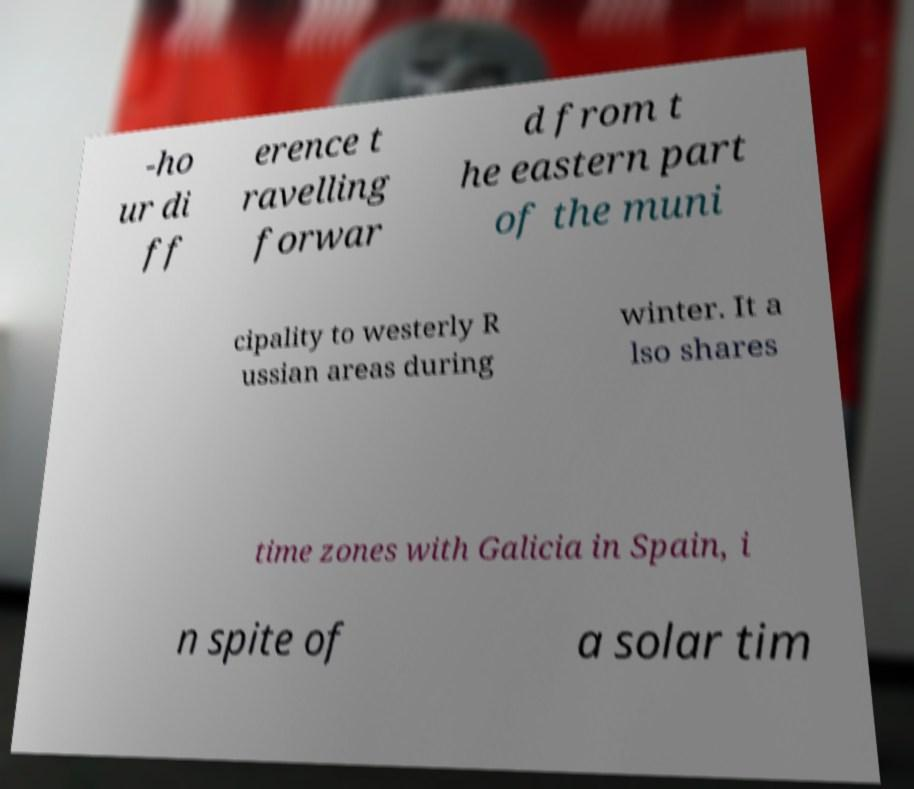Please identify and transcribe the text found in this image. -ho ur di ff erence t ravelling forwar d from t he eastern part of the muni cipality to westerly R ussian areas during winter. It a lso shares time zones with Galicia in Spain, i n spite of a solar tim 